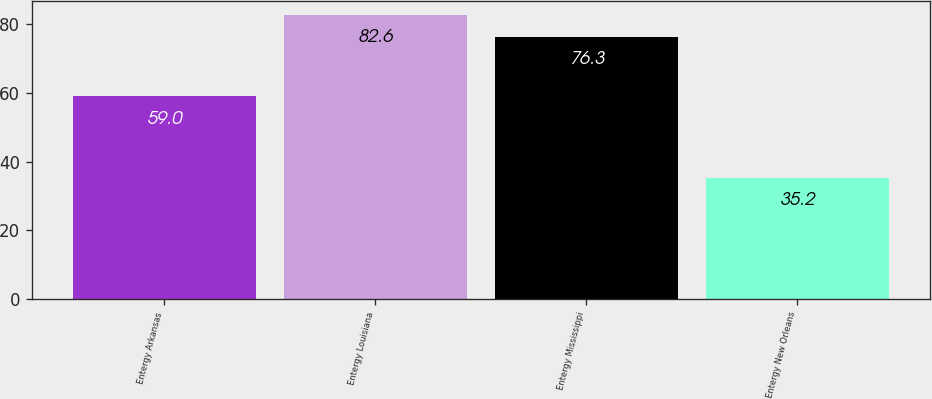Convert chart. <chart><loc_0><loc_0><loc_500><loc_500><bar_chart><fcel>Entergy Arkansas<fcel>Entergy Louisiana<fcel>Entergy Mississippi<fcel>Entergy New Orleans<nl><fcel>59<fcel>82.6<fcel>76.3<fcel>35.2<nl></chart> 